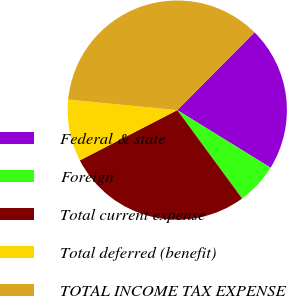Convert chart to OTSL. <chart><loc_0><loc_0><loc_500><loc_500><pie_chart><fcel>Federal & state<fcel>Foreign<fcel>Total current expense<fcel>Total deferred (benefit)<fcel>TOTAL INCOME TAX EXPENSE<nl><fcel>21.36%<fcel>6.13%<fcel>27.49%<fcel>9.11%<fcel>35.92%<nl></chart> 